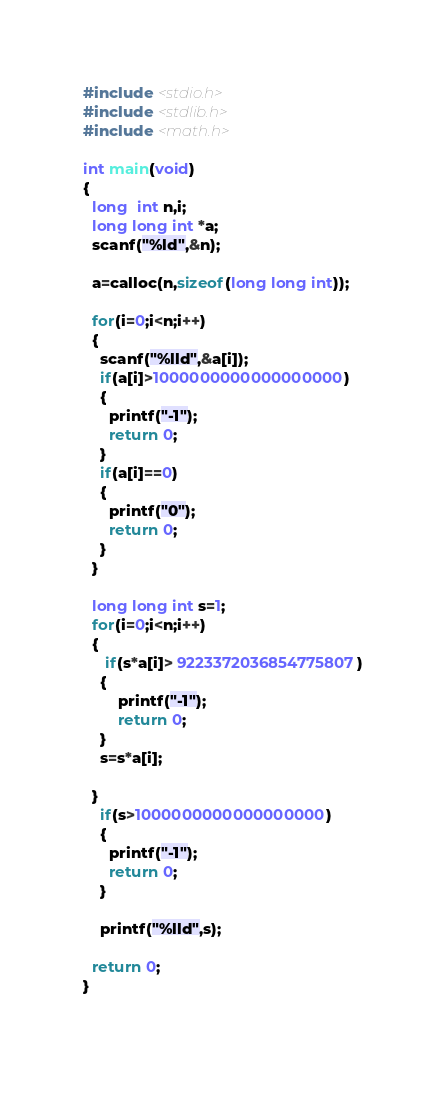Convert code to text. <code><loc_0><loc_0><loc_500><loc_500><_C_>#include <stdio.h>
#include <stdlib.h>
#include <math.h>

int main(void)
{
  long  int n,i;
  long long int *a;
  scanf("%ld",&n);
  
  a=calloc(n,sizeof(long long int));
    
  for(i=0;i<n;i++)
  {
    scanf("%lld",&a[i]);
    if(a[i]>1000000000000000000)
    {
      printf("-1");
      return 0;
    }
    if(a[i]==0)
    {
      printf("0");
      return 0;
    }
  }
  
  long long int s=1;
  for(i=0;i<n;i++)
  {
     if(s*a[i]> 9223372036854775807)
    {
      	printf("-1");
    	return 0;
    }
    s=s*a[i];
   
  }
    if(s>1000000000000000000)
    {
      printf("-1");
      return 0;
    }
  
  	printf("%lld",s);
  
  return 0;
}
  
</code> 